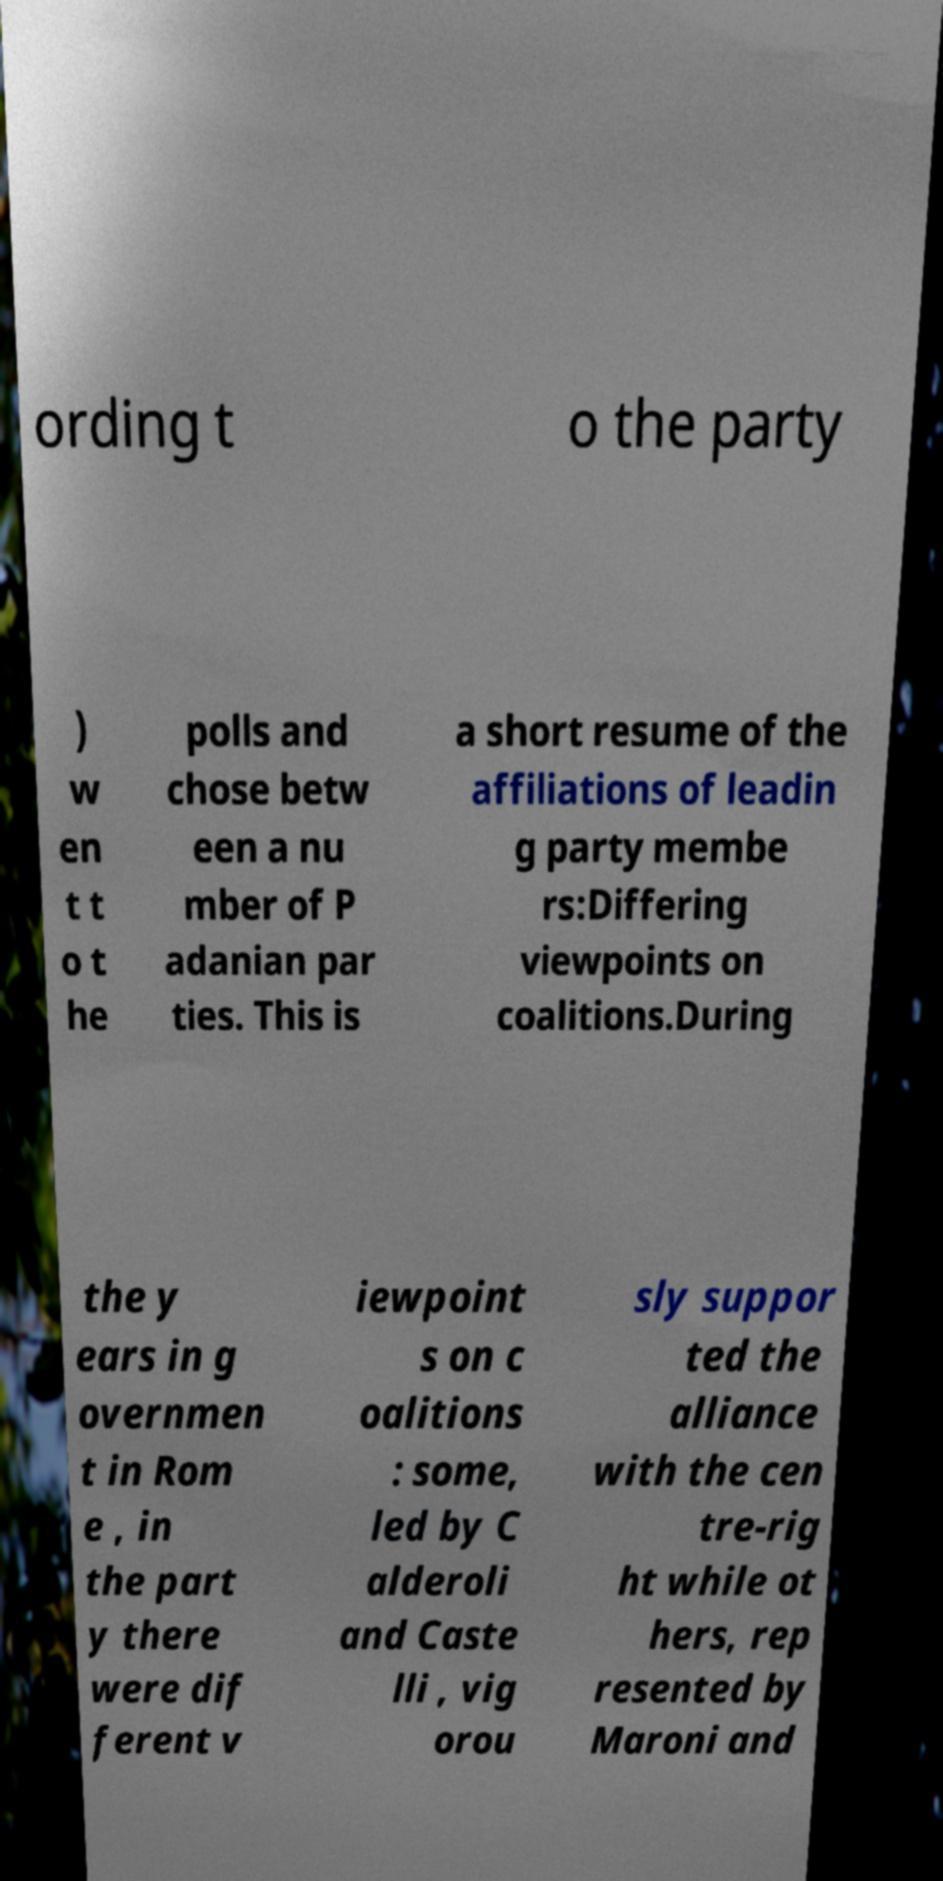Please read and relay the text visible in this image. What does it say? ording t o the party ) w en t t o t he polls and chose betw een a nu mber of P adanian par ties. This is a short resume of the affiliations of leadin g party membe rs:Differing viewpoints on coalitions.During the y ears in g overnmen t in Rom e , in the part y there were dif ferent v iewpoint s on c oalitions : some, led by C alderoli and Caste lli , vig orou sly suppor ted the alliance with the cen tre-rig ht while ot hers, rep resented by Maroni and 